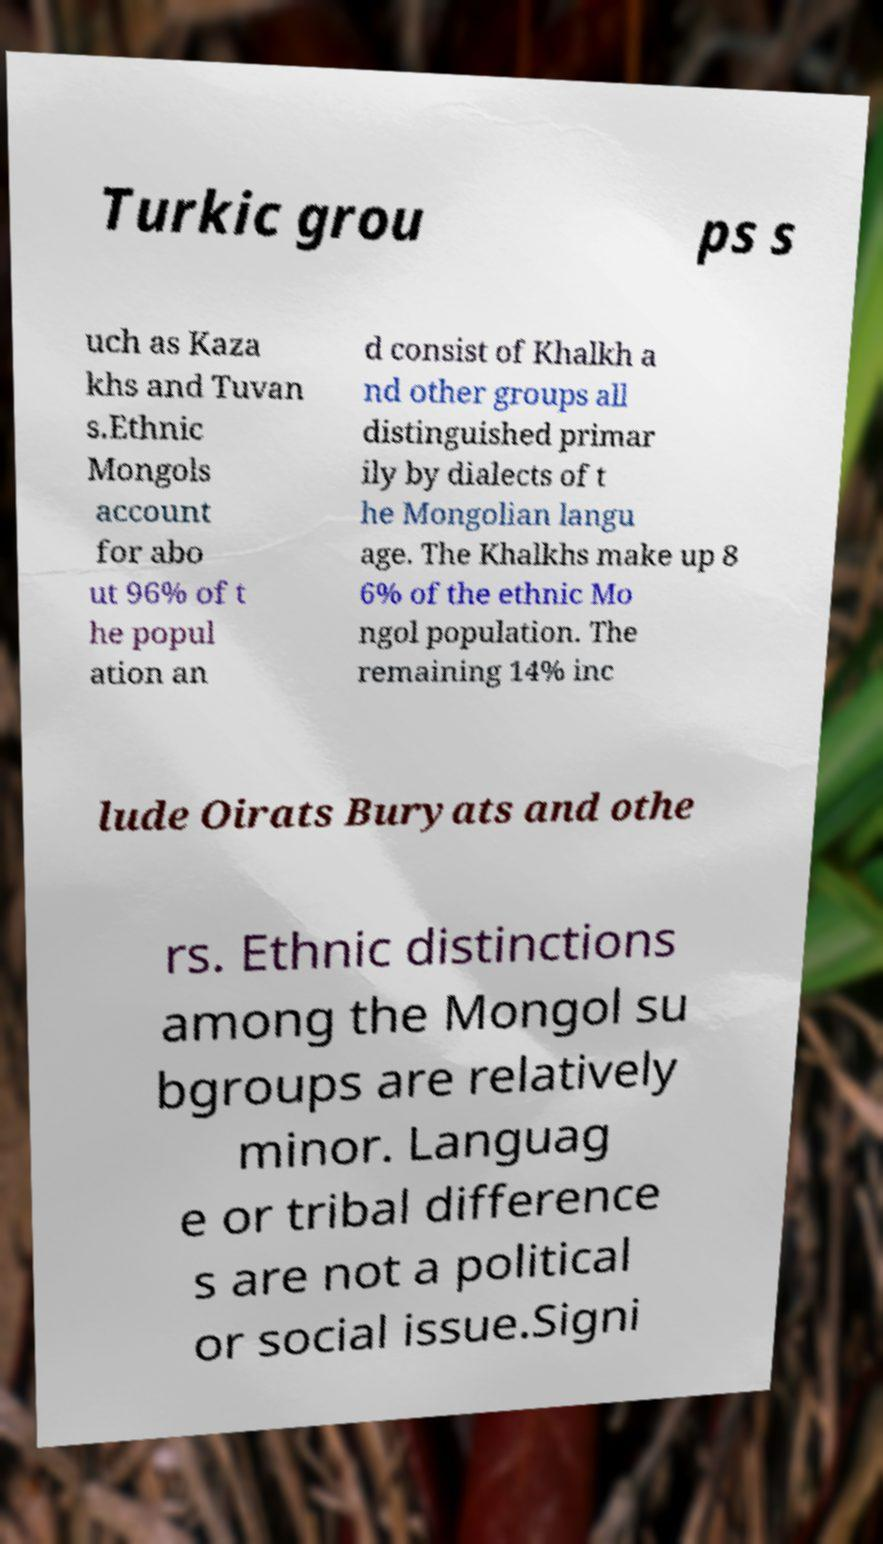Please read and relay the text visible in this image. What does it say? Turkic grou ps s uch as Kaza khs and Tuvan s.Ethnic Mongols account for abo ut 96% of t he popul ation an d consist of Khalkh a nd other groups all distinguished primar ily by dialects of t he Mongolian langu age. The Khalkhs make up 8 6% of the ethnic Mo ngol population. The remaining 14% inc lude Oirats Buryats and othe rs. Ethnic distinctions among the Mongol su bgroups are relatively minor. Languag e or tribal difference s are not a political or social issue.Signi 